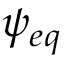<formula> <loc_0><loc_0><loc_500><loc_500>\psi _ { e q }</formula> 